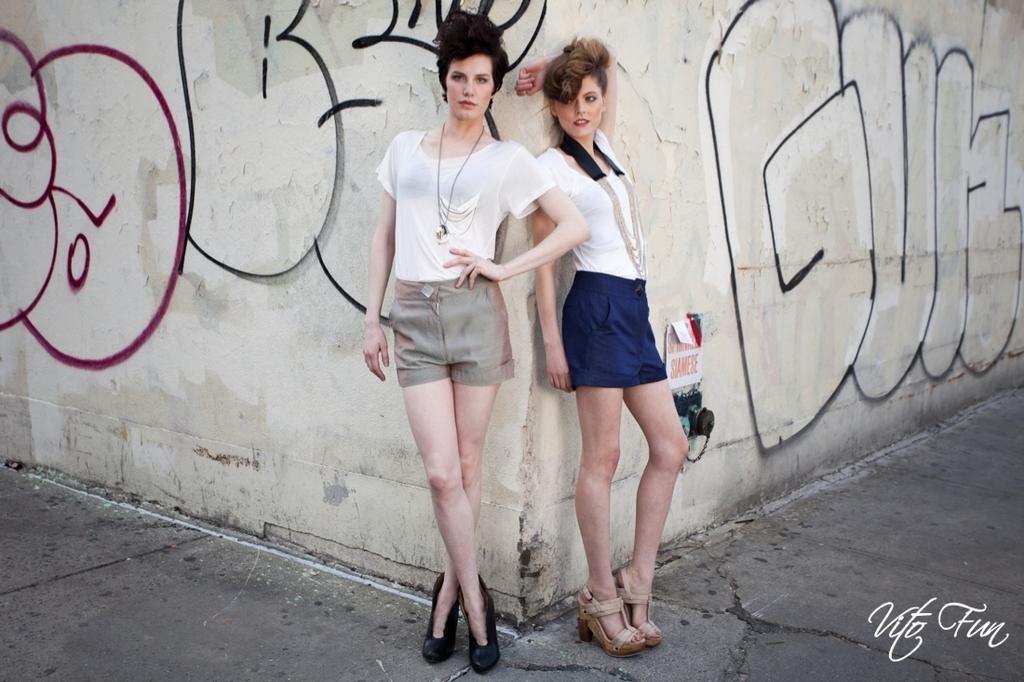Please provide a concise description of this image. In this image we can see two persons standing on the floor, in the background, we can see the wall, on the wall, we can see the objects. 